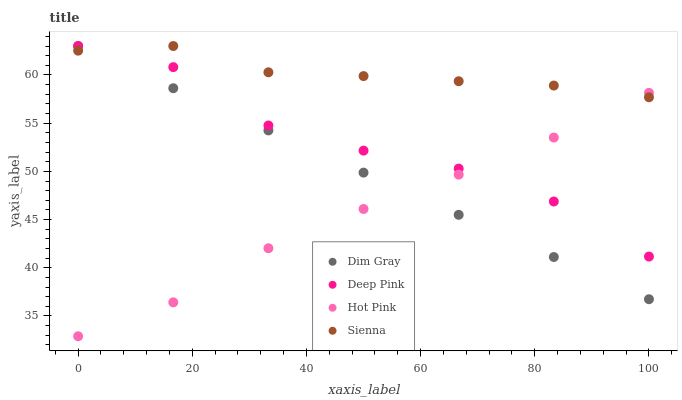Does Hot Pink have the minimum area under the curve?
Answer yes or no. Yes. Does Sienna have the maximum area under the curve?
Answer yes or no. Yes. Does Dim Gray have the minimum area under the curve?
Answer yes or no. No. Does Dim Gray have the maximum area under the curve?
Answer yes or no. No. Is Dim Gray the smoothest?
Answer yes or no. Yes. Is Deep Pink the roughest?
Answer yes or no. Yes. Is Deep Pink the smoothest?
Answer yes or no. No. Is Dim Gray the roughest?
Answer yes or no. No. Does Hot Pink have the lowest value?
Answer yes or no. Yes. Does Dim Gray have the lowest value?
Answer yes or no. No. Does Deep Pink have the highest value?
Answer yes or no. Yes. Does Hot Pink have the highest value?
Answer yes or no. No. Does Deep Pink intersect Hot Pink?
Answer yes or no. Yes. Is Deep Pink less than Hot Pink?
Answer yes or no. No. Is Deep Pink greater than Hot Pink?
Answer yes or no. No. 